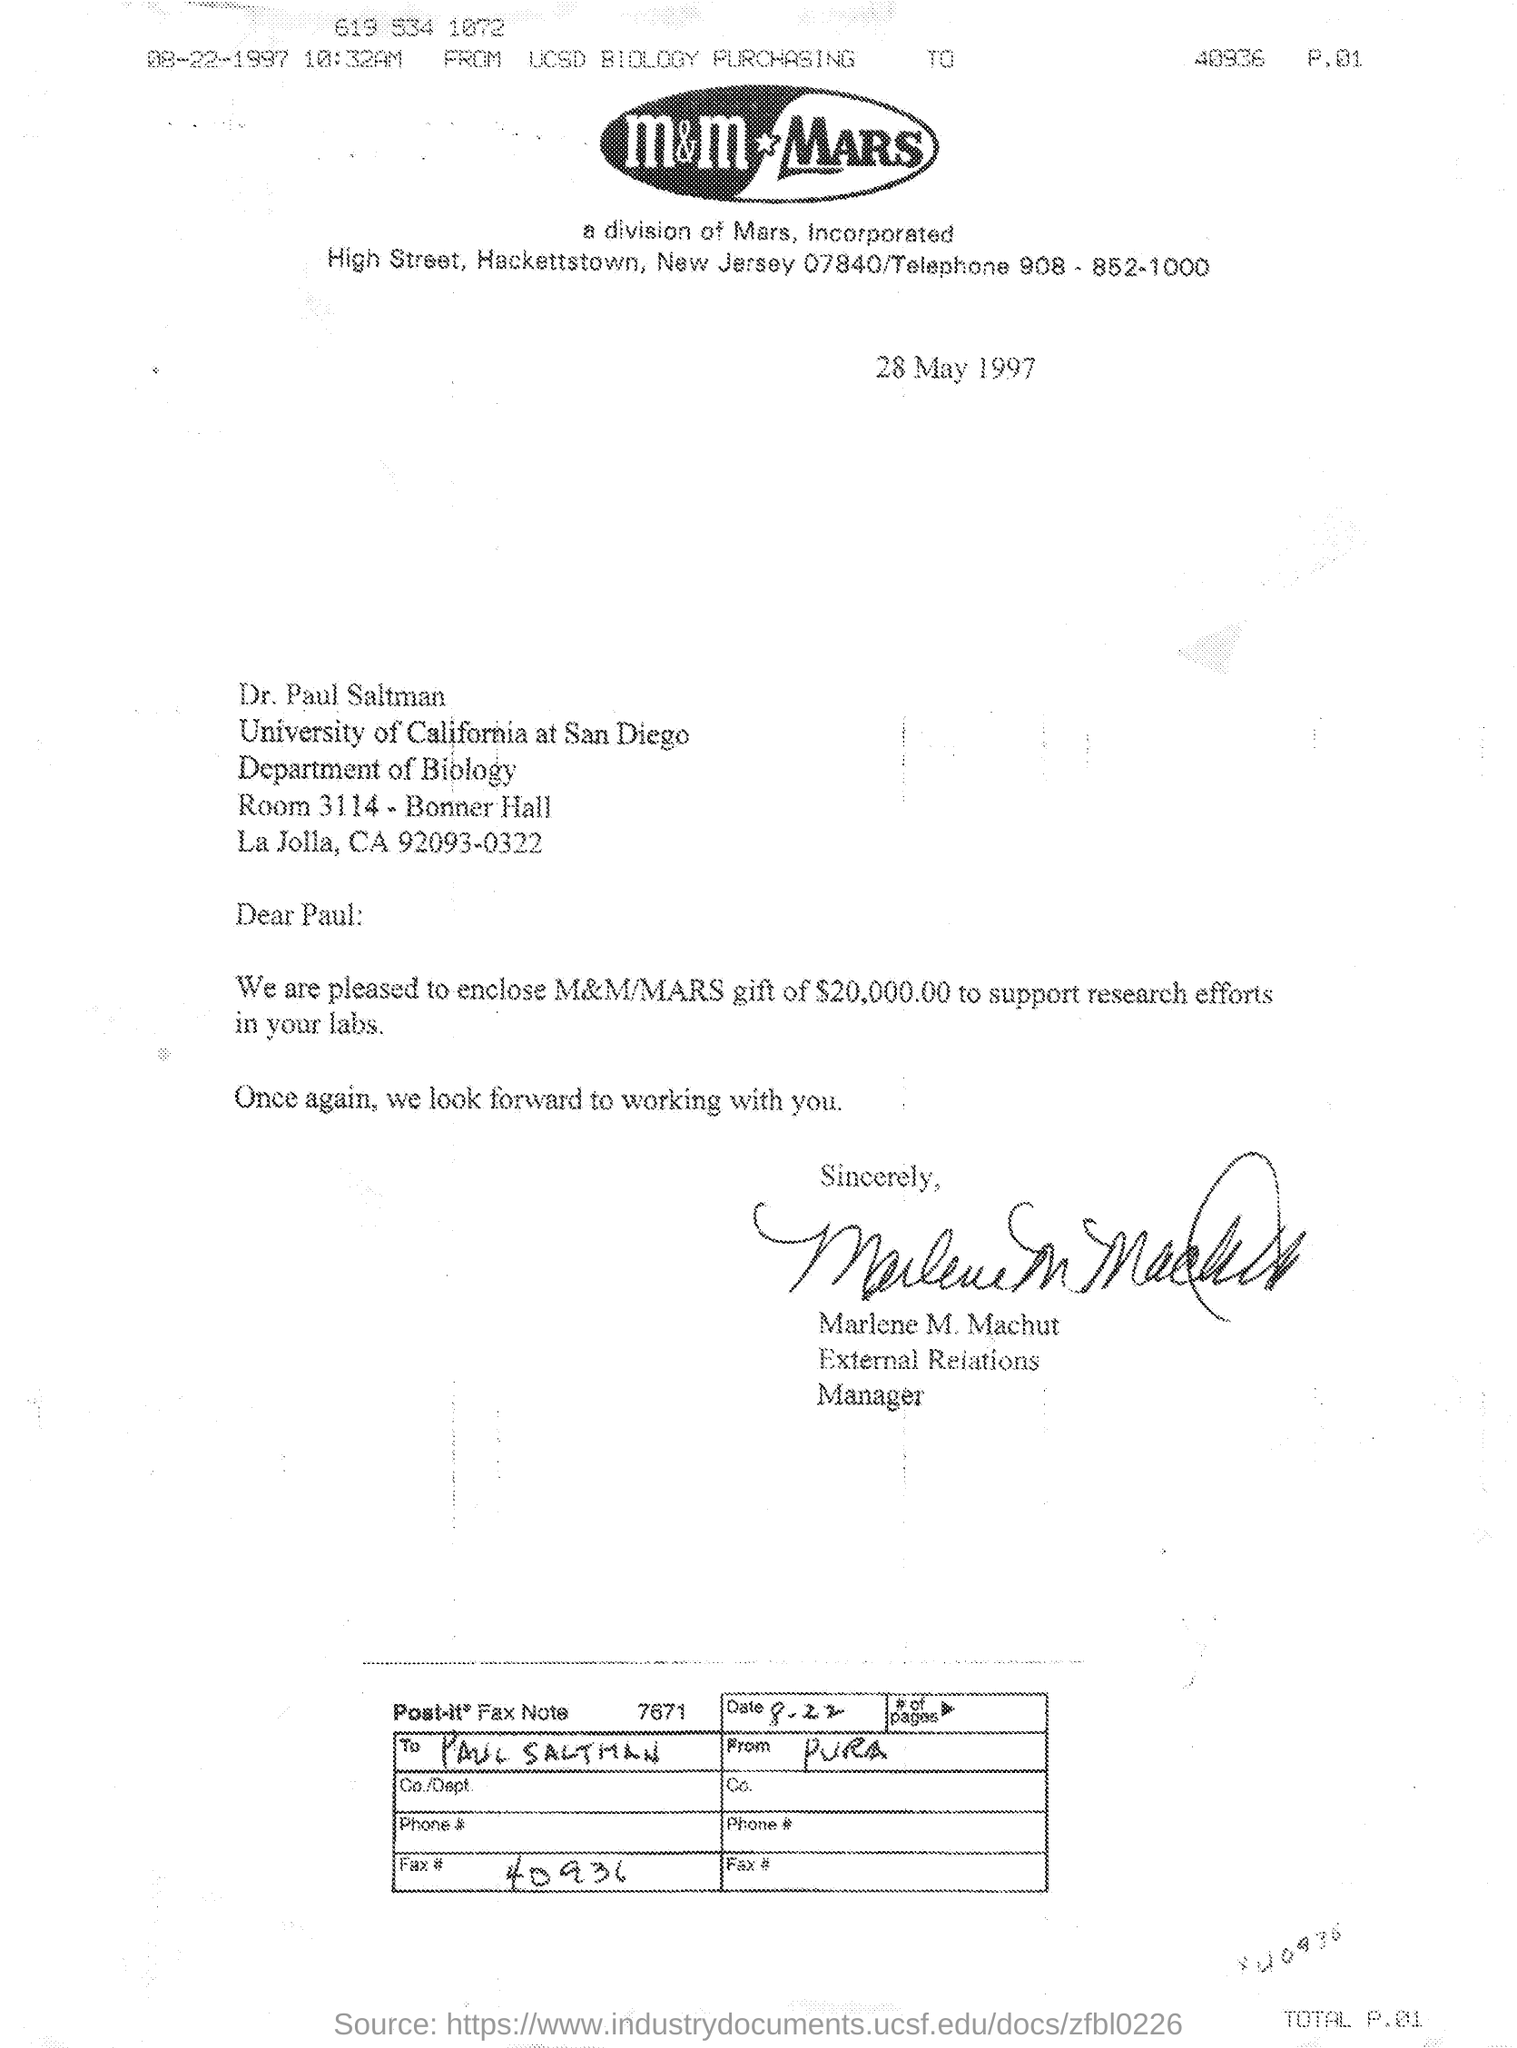How much amount is given to Paul as the gift to support research efforts in his labs?
Your answer should be compact. 20,000.00$. Which is the date mentioned in the letter?
Make the answer very short. 28 May 1997. Who send the gift?
Make the answer very short. MARLENE M. MACHUT. 